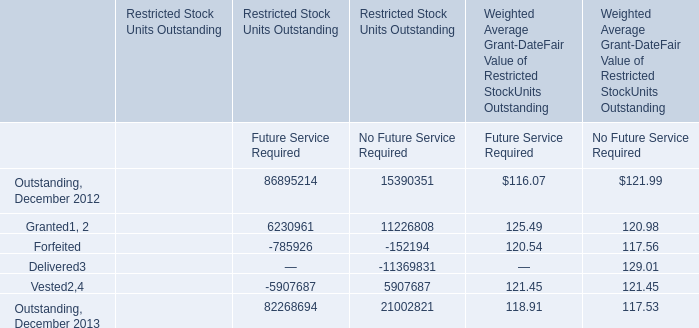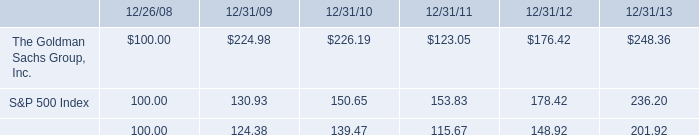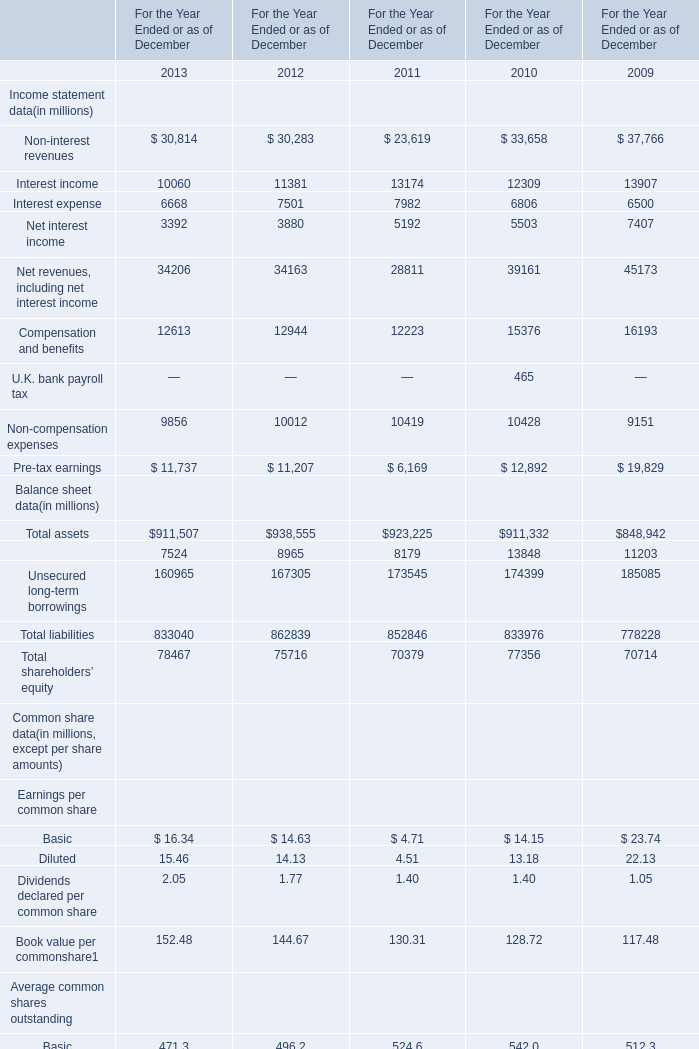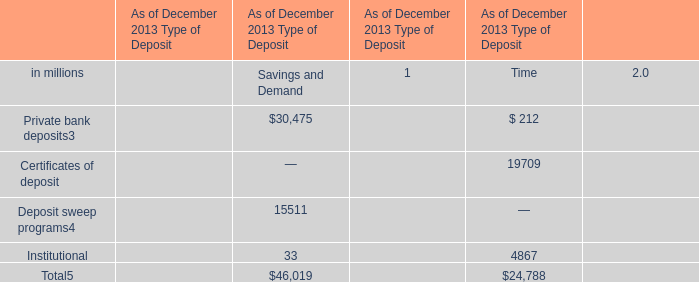What's the growth rate of Net interest income in 2011? 
Computations: ((5192 - 5503) / 5503)
Answer: -0.05651. 